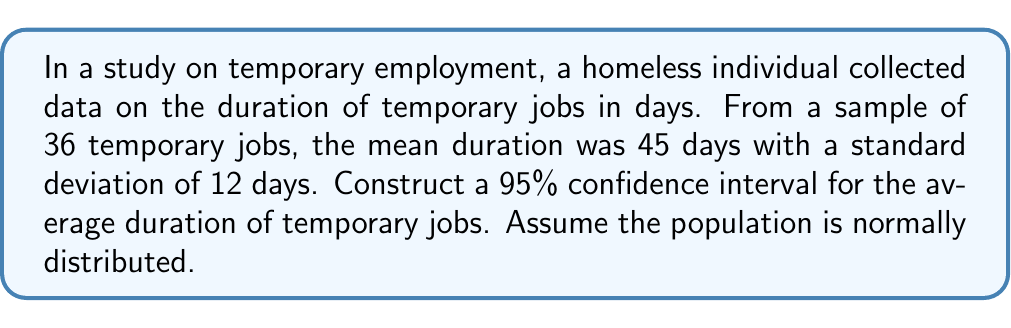Teach me how to tackle this problem. To construct a 95% confidence interval for the average duration of temporary jobs, we'll follow these steps:

1. Identify the given information:
   - Sample size: $n = 36$
   - Sample mean: $\bar{x} = 45$ days
   - Sample standard deviation: $s = 12$ days
   - Confidence level: 95% (α = 0.05)

2. Determine the critical value:
   For a 95% confidence interval with 35 degrees of freedom (n - 1), we use the t-distribution. The critical value is $t_{0.025, 35} = 2.030$.

3. Calculate the margin of error:
   Margin of error = $t_{0.025, 35} \cdot \frac{s}{\sqrt{n}}$
   $$ \text{Margin of error} = 2.030 \cdot \frac{12}{\sqrt{36}} = 2.030 \cdot 2 = 4.06 $$

4. Construct the confidence interval:
   Lower bound = $\bar{x} - \text{Margin of error}$
   Upper bound = $\bar{x} + \text{Margin of error}$

   $$ 45 - 4.06 \leq \mu \leq 45 + 4.06 $$
   $$ 40.94 \leq \mu \leq 49.06 $$

Therefore, we can be 95% confident that the true population mean duration of temporary jobs falls between 40.94 and 49.06 days.
Answer: (40.94, 49.06) days 